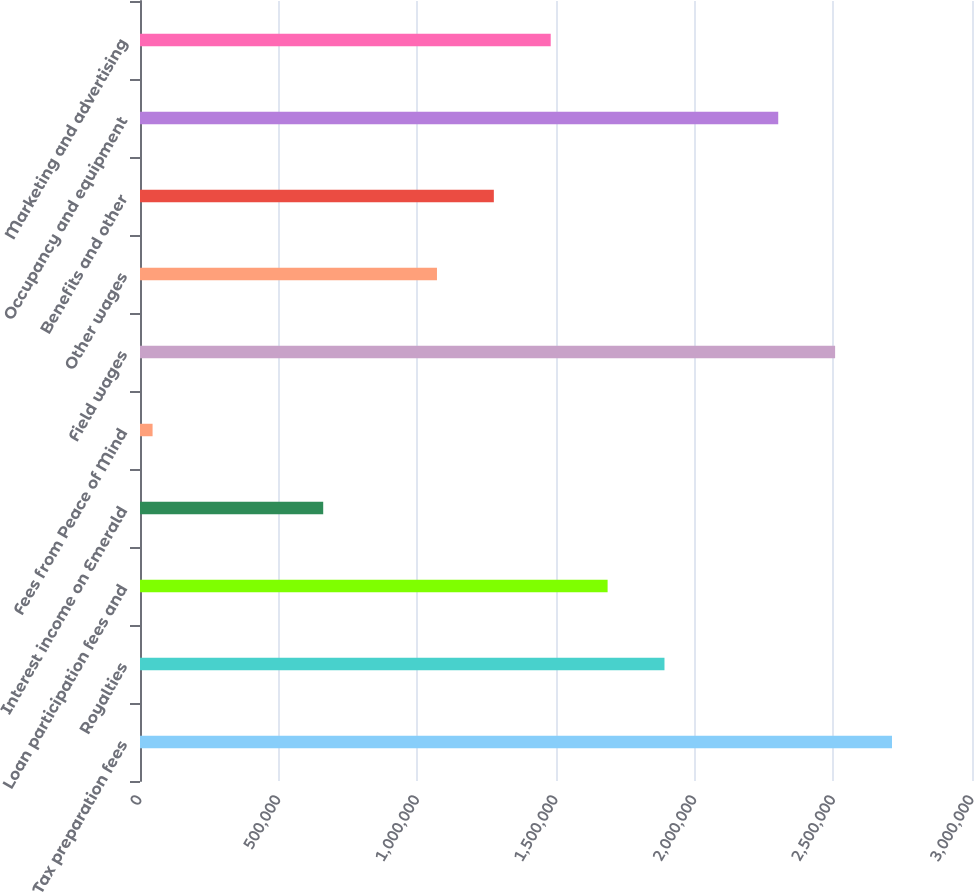Convert chart. <chart><loc_0><loc_0><loc_500><loc_500><bar_chart><fcel>Tax preparation fees<fcel>Royalties<fcel>Loan participation fees and<fcel>Interest income on Emerald<fcel>Fees from Peace of Mind<fcel>Field wages<fcel>Other wages<fcel>Benefits and other<fcel>Occupancy and equipment<fcel>Marketing and advertising<nl><fcel>2.71151e+06<fcel>1.89115e+06<fcel>1.68606e+06<fcel>660608<fcel>45339<fcel>2.50642e+06<fcel>1.07079e+06<fcel>1.27588e+06<fcel>2.30133e+06<fcel>1.48097e+06<nl></chart> 